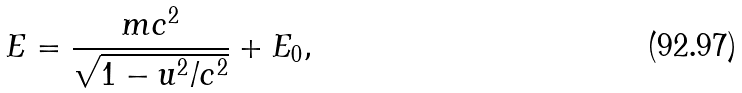<formula> <loc_0><loc_0><loc_500><loc_500>E = \frac { m c ^ { 2 } } { \sqrt { 1 - u ^ { 2 } / c ^ { 2 } } } + E _ { 0 } ,</formula> 